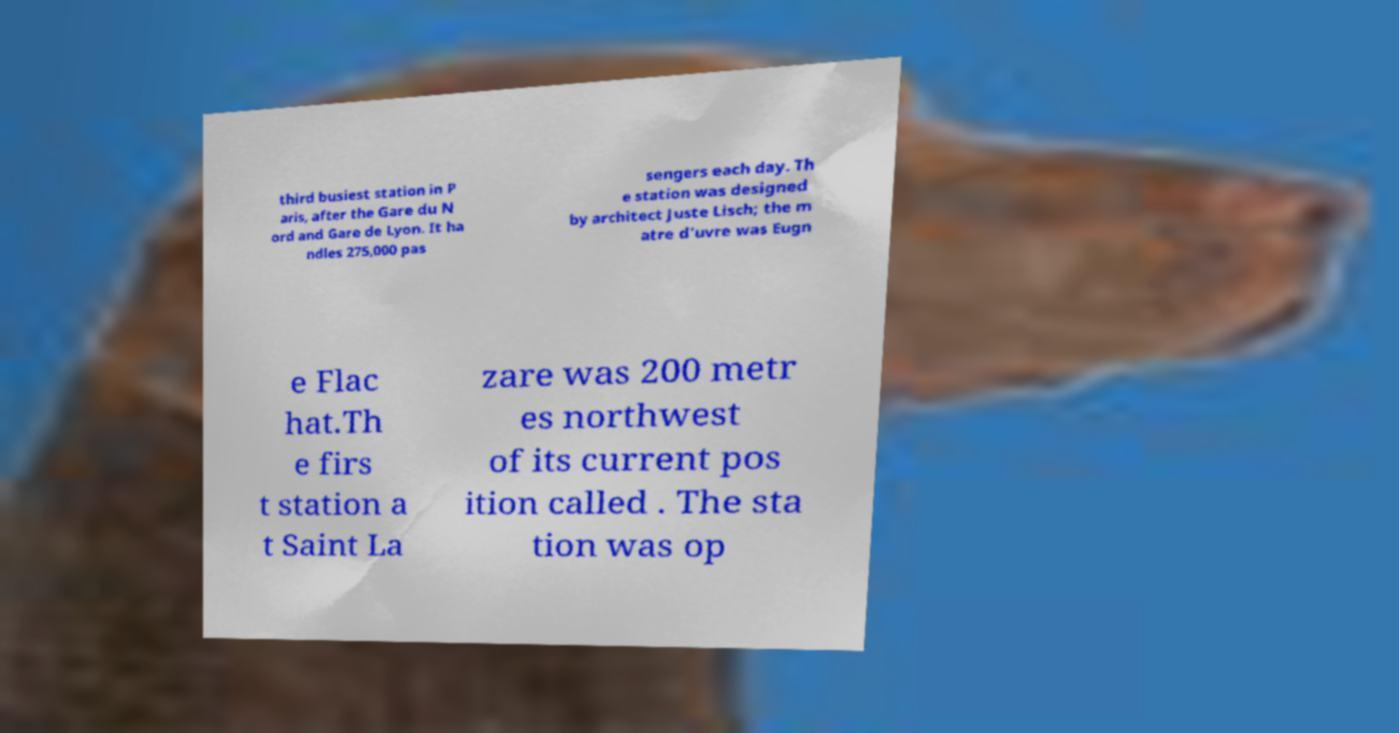Could you assist in decoding the text presented in this image and type it out clearly? third busiest station in P aris, after the Gare du N ord and Gare de Lyon. It ha ndles 275,000 pas sengers each day. Th e station was designed by architect Juste Lisch; the m atre d'uvre was Eugn e Flac hat.Th e firs t station a t Saint La zare was 200 metr es northwest of its current pos ition called . The sta tion was op 